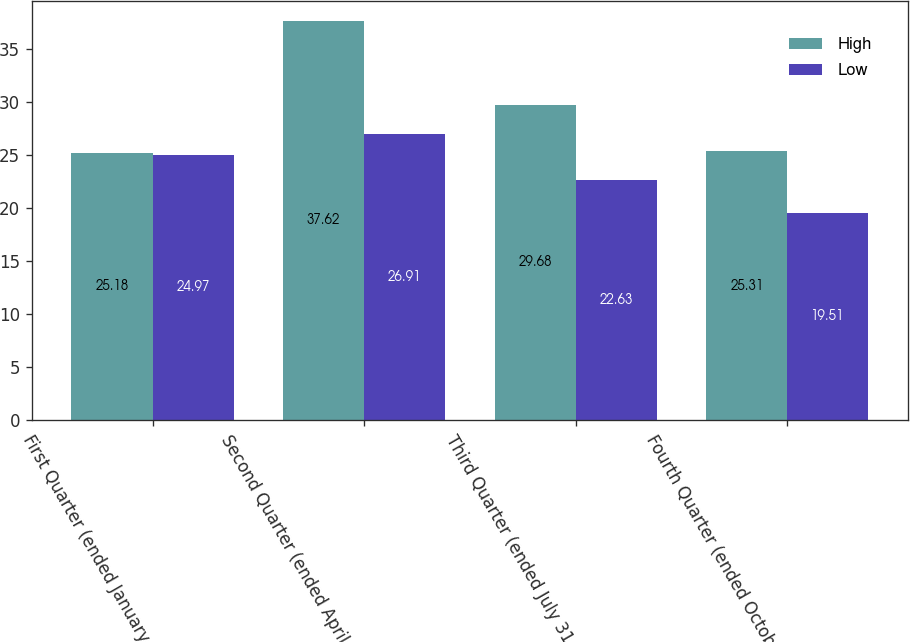<chart> <loc_0><loc_0><loc_500><loc_500><stacked_bar_chart><ecel><fcel>First Quarter (ended January<fcel>Second Quarter (ended April 30<fcel>Third Quarter (ended July 31<fcel>Fourth Quarter (ended October<nl><fcel>High<fcel>25.18<fcel>37.62<fcel>29.68<fcel>25.31<nl><fcel>Low<fcel>24.97<fcel>26.91<fcel>22.63<fcel>19.51<nl></chart> 